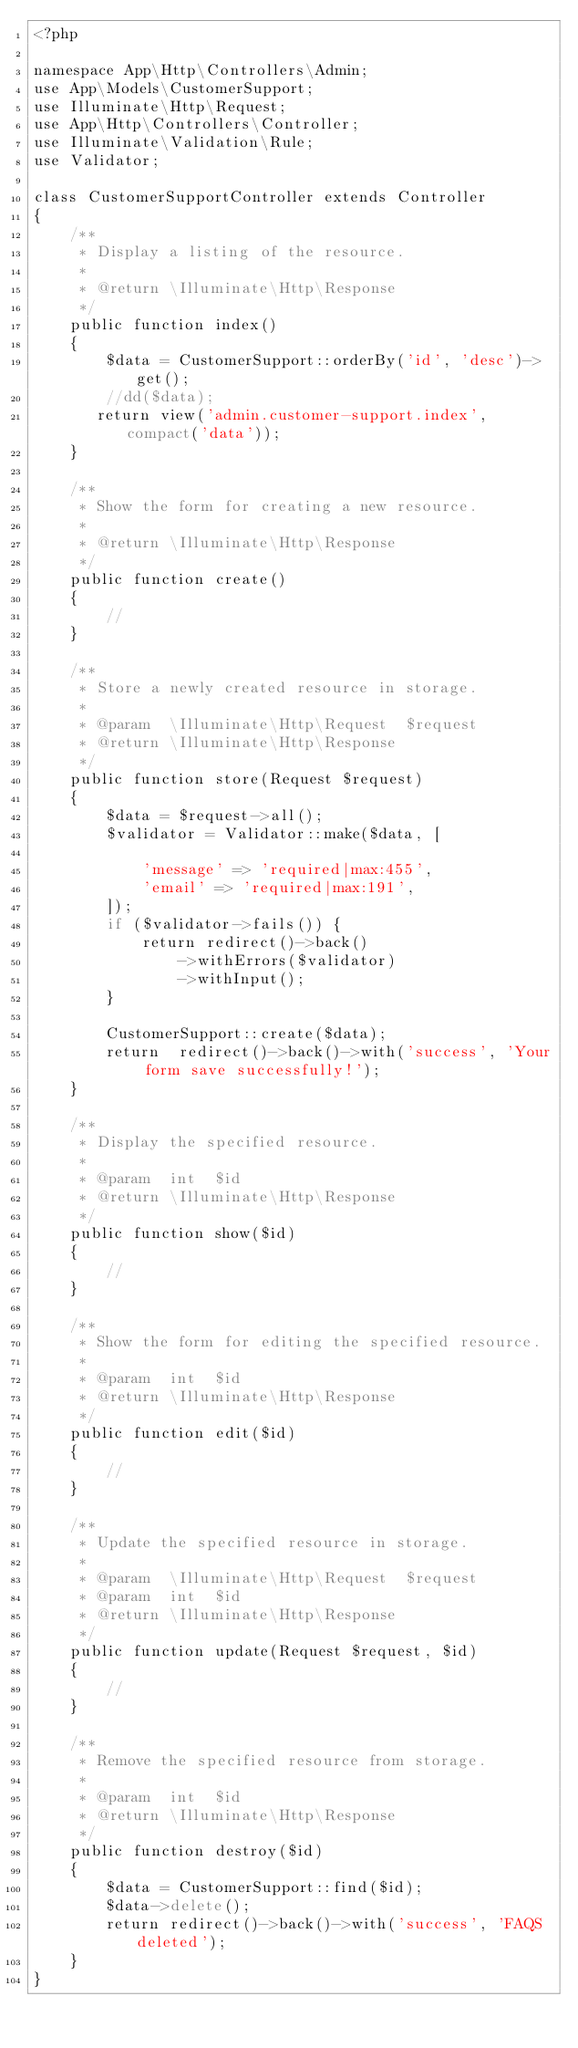<code> <loc_0><loc_0><loc_500><loc_500><_PHP_><?php

namespace App\Http\Controllers\Admin;
use App\Models\CustomerSupport;
use Illuminate\Http\Request;
use App\Http\Controllers\Controller;
use Illuminate\Validation\Rule;
use Validator;

class CustomerSupportController extends Controller
{
    /**
     * Display a listing of the resource.
     *
     * @return \Illuminate\Http\Response
     */
    public function index()
    {
        $data = CustomerSupport::orderBy('id', 'desc')->get();
        //dd($data);
       return view('admin.customer-support.index', compact('data'));
    }

    /**
     * Show the form for creating a new resource.
     *
     * @return \Illuminate\Http\Response
     */
    public function create()
    {
        //
    }

    /**
     * Store a newly created resource in storage.
     *
     * @param  \Illuminate\Http\Request  $request
     * @return \Illuminate\Http\Response
     */
    public function store(Request $request)
    {
        $data = $request->all();
        $validator = Validator::make($data, [
           
            'message' => 'required|max:455',
            'email' => 'required|max:191',
        ]);
        if ($validator->fails()) {
            return redirect()->back()
                ->withErrors($validator)
                ->withInput();
        }
        
        CustomerSupport::create($data);
        return  redirect()->back()->with('success', 'Your form save successfully!');
    }

    /**
     * Display the specified resource.
     *
     * @param  int  $id
     * @return \Illuminate\Http\Response
     */
    public function show($id)
    {
        //
    }

    /**
     * Show the form for editing the specified resource.
     *
     * @param  int  $id
     * @return \Illuminate\Http\Response
     */
    public function edit($id)
    {
        //
    }

    /**
     * Update the specified resource in storage.
     *
     * @param  \Illuminate\Http\Request  $request
     * @param  int  $id
     * @return \Illuminate\Http\Response
     */
    public function update(Request $request, $id)
    {
        //
    }

    /**
     * Remove the specified resource from storage.
     *
     * @param  int  $id
     * @return \Illuminate\Http\Response
     */
    public function destroy($id)
    {
        $data = CustomerSupport::find($id);
        $data->delete();
        return redirect()->back()->with('success', 'FAQS deleted');
    }
}
</code> 